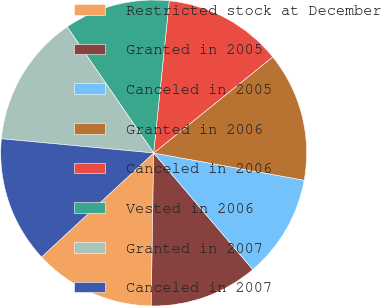Convert chart to OTSL. <chart><loc_0><loc_0><loc_500><loc_500><pie_chart><fcel>Restricted stock at December<fcel>Granted in 2005<fcel>Canceled in 2005<fcel>Granted in 2006<fcel>Canceled in 2006<fcel>Vested in 2006<fcel>Granted in 2007<fcel>Canceled in 2007<nl><fcel>12.84%<fcel>11.47%<fcel>10.93%<fcel>13.66%<fcel>12.57%<fcel>11.2%<fcel>13.94%<fcel>13.39%<nl></chart> 